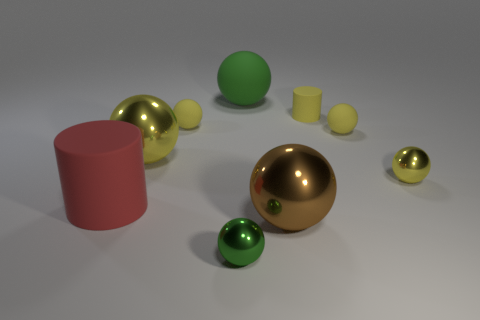Subtract all brown cubes. How many yellow spheres are left? 4 Subtract 3 spheres. How many spheres are left? 4 Subtract all green balls. How many balls are left? 5 Subtract all large green rubber balls. How many balls are left? 6 Subtract all blue balls. Subtract all purple cubes. How many balls are left? 7 Add 1 brown spheres. How many objects exist? 10 Subtract all cylinders. How many objects are left? 7 Subtract all small green cubes. Subtract all tiny green spheres. How many objects are left? 8 Add 5 green rubber objects. How many green rubber objects are left? 6 Add 8 tiny green metal blocks. How many tiny green metal blocks exist? 8 